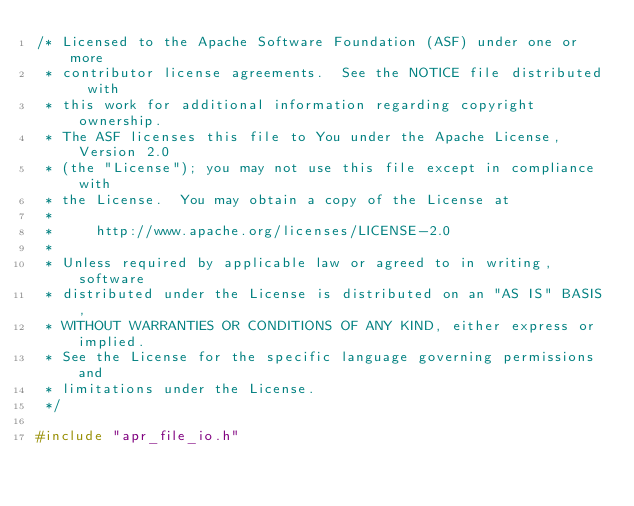Convert code to text. <code><loc_0><loc_0><loc_500><loc_500><_C_>/* Licensed to the Apache Software Foundation (ASF) under one or more
 * contributor license agreements.  See the NOTICE file distributed with
 * this work for additional information regarding copyright ownership.
 * The ASF licenses this file to You under the Apache License, Version 2.0
 * (the "License"); you may not use this file except in compliance with
 * the License.  You may obtain a copy of the License at
 *
 *     http://www.apache.org/licenses/LICENSE-2.0
 *
 * Unless required by applicable law or agreed to in writing, software
 * distributed under the License is distributed on an "AS IS" BASIS,
 * WITHOUT WARRANTIES OR CONDITIONS OF ANY KIND, either express or implied.
 * See the License for the specific language governing permissions and
 * limitations under the License.
 */

#include "apr_file_io.h"</code> 